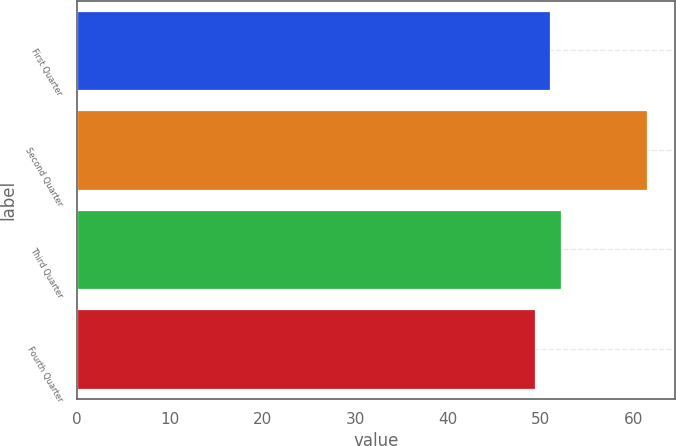Convert chart to OTSL. <chart><loc_0><loc_0><loc_500><loc_500><bar_chart><fcel>First Quarter<fcel>Second Quarter<fcel>Third Quarter<fcel>Fourth Quarter<nl><fcel>51.02<fcel>61.47<fcel>52.23<fcel>49.38<nl></chart> 